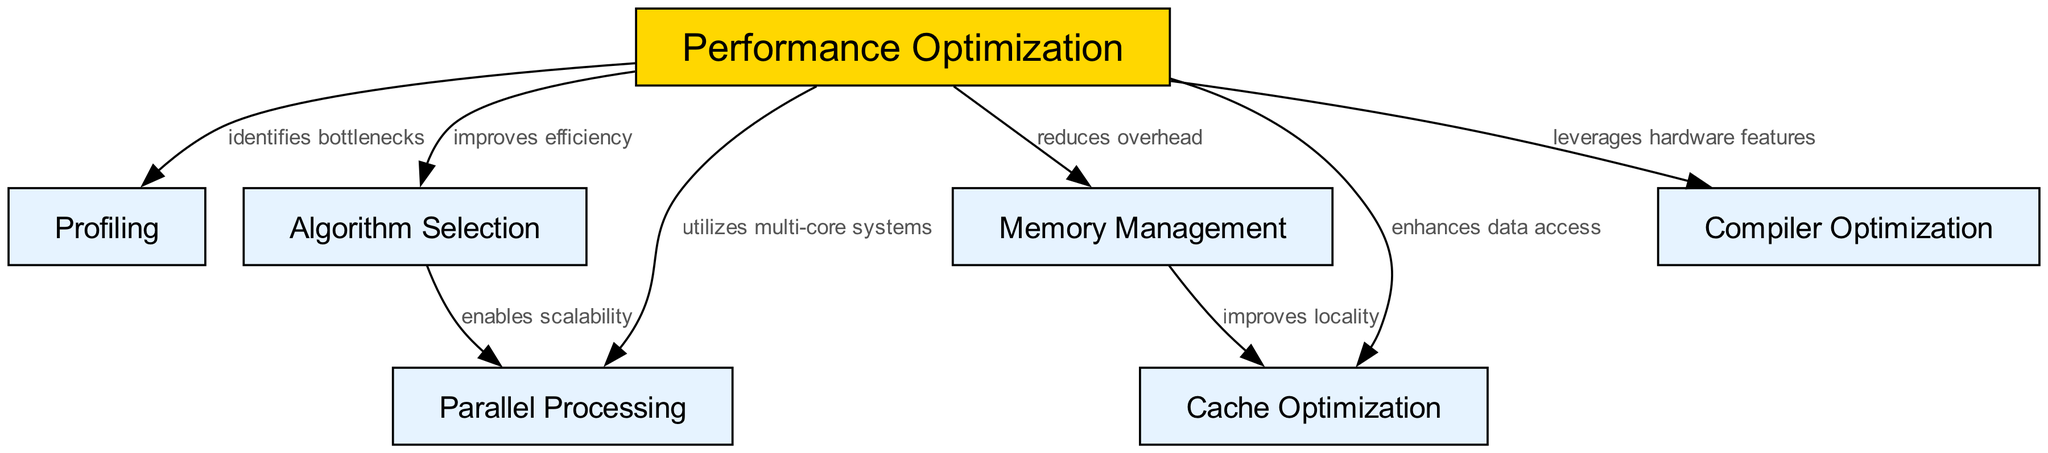What is the total number of nodes in the diagram? The diagram contains a list of nodes under the "nodes" section in the data. By counting each entry in the list, we find there are seven nodes present: performance optimization, profiling, algorithm selection, parallel processing, memory management, cache optimization, and compiler optimization.
Answer: 7 What is the relationship between performance optimization and memory management? In the edges section, there is a direct edge that goes from performance optimization to memory management with the label "reduces overhead". This indicates that performance optimization directly influences memory management by minimizing the overhead involved.
Answer: reduces overhead Which node is labeled with "enhances data access"? In the edges section of the diagram, there is an edge from performance optimization to cache optimization labeled "enhances data access". Thus, cache optimization is the only node that specifically has this label associated with it.
Answer: cache optimization How many edges are connected to the performance optimization node? By inspecting the edges section, we can see that performance optimization is connected to six other nodes: profiling, algorithm selection, parallel processing, memory management, cache optimization, and compiler optimization. This totals to six edges directly linked to performance optimization.
Answer: 6 What does algorithm selection enable in terms of processing? There is an edge from algorithm selection to parallel processing labeled "enables scalability". This shows that the selection of the appropriate algorithm has the capability to allow the system to scale effectively when using parallel processing methods.
Answer: scalability Which node is linked to both cache optimization and memory management? By reviewing the edges, we see that there is a connection from memory management to cache optimization, indicated by the label "improves locality". This shows that memory management directly affects cache optimization.
Answer: cache optimization What is the function of profiling in performance optimization? The edge from performance optimization to profiling is labeled "identifies bottlenecks". This indicates that profiling serves to spot problems or inefficiencies in the system that hinder performance.
Answer: identifies bottlenecks 